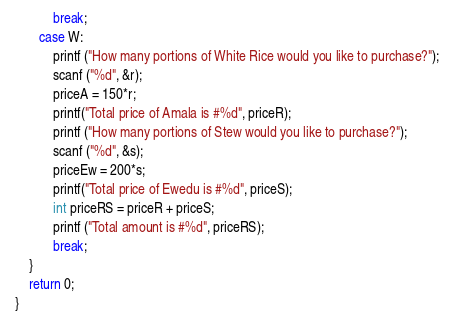<code> <loc_0><loc_0><loc_500><loc_500><_C_>     		break;
     	case W:
     		printf ("How many portions of White Rice would you like to purchase?");
     		scanf ("%d", &r);
     		priceA = 150*r;
     		printf("Total price of Amala is #%d", priceR);
     		printf ("How many portions of Stew would you like to purchase?");
     		scanf ("%d", &s);
     		priceEw = 200*s;
     		printf("Total price of Ewedu is #%d", priceS);
     		int priceRS = priceR + priceS;
     		printf ("Total amount is #%d", priceRS);
     		break;
     }
     return 0;
 }
</code> 